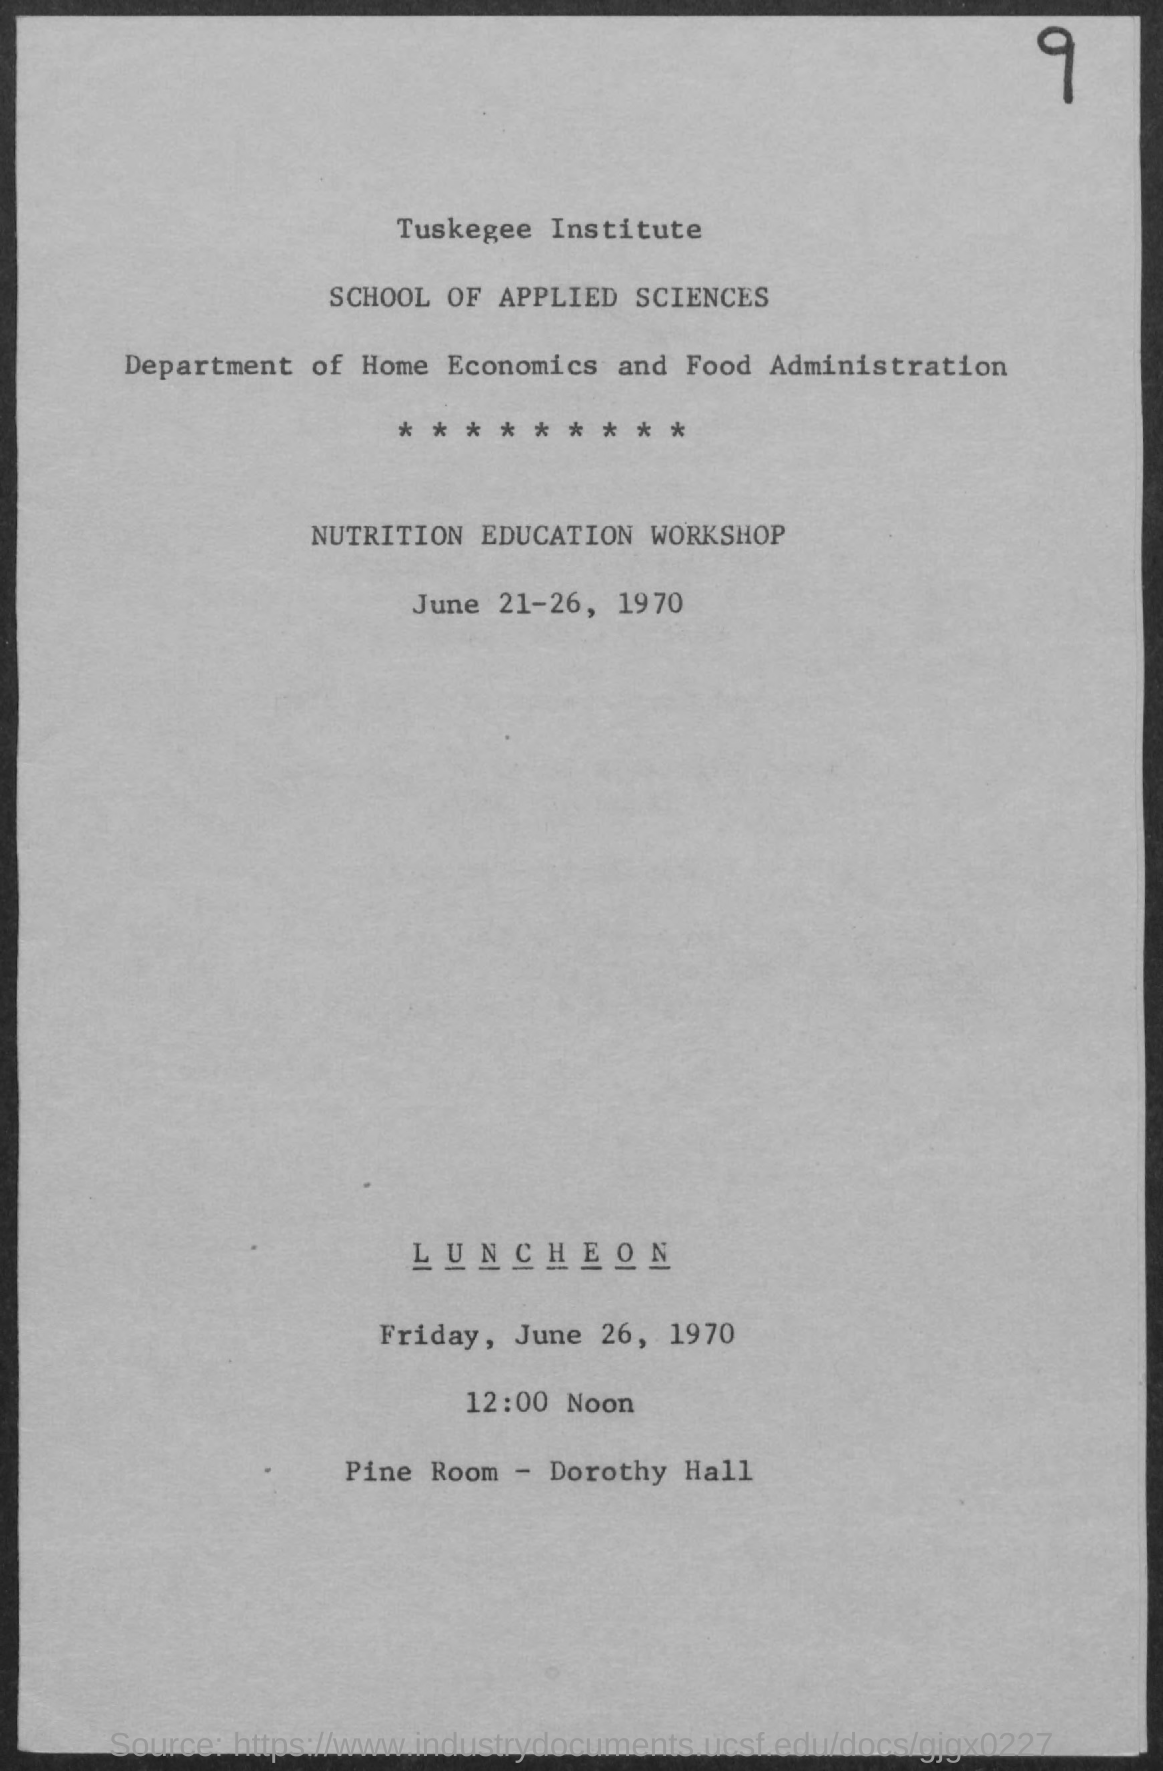When is the Nutrition Education Workshop?
Offer a very short reply. June 21-26, 1970. What time is the Luncheon?
Provide a succinct answer. 12:00 noon. Where is the Luncheon?
Ensure brevity in your answer.  Pine Room - Dorothy Hall. 